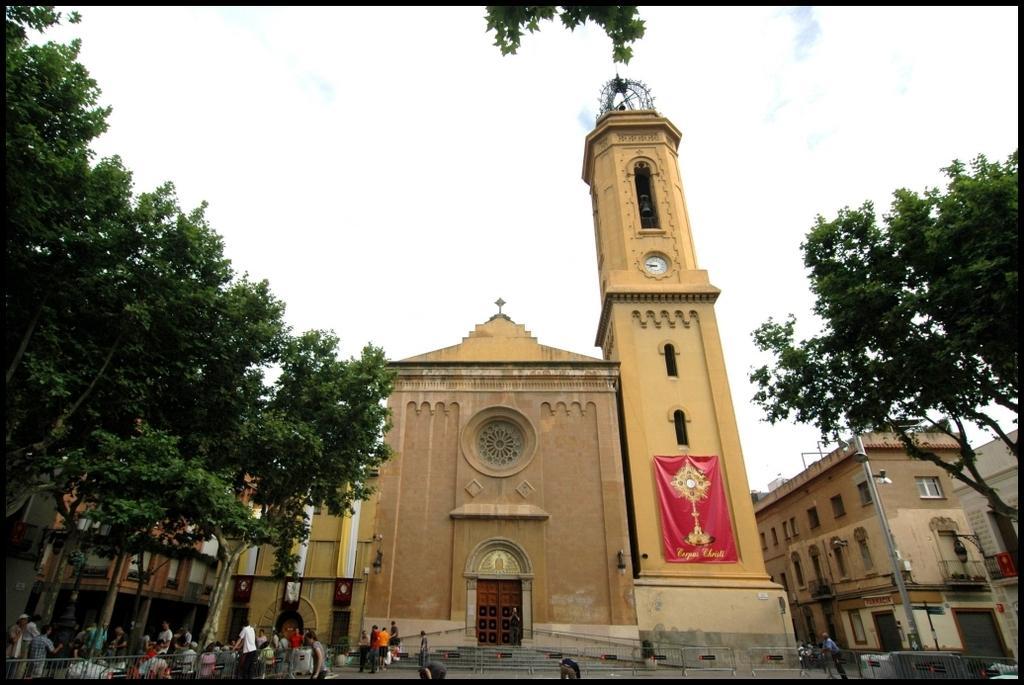In one or two sentences, can you explain what this image depicts? In this image we can see a few buildings, on the building we can see a clock and a poster, there are some trees, people, grille, staircase and a door, in the background we can see the sky. 